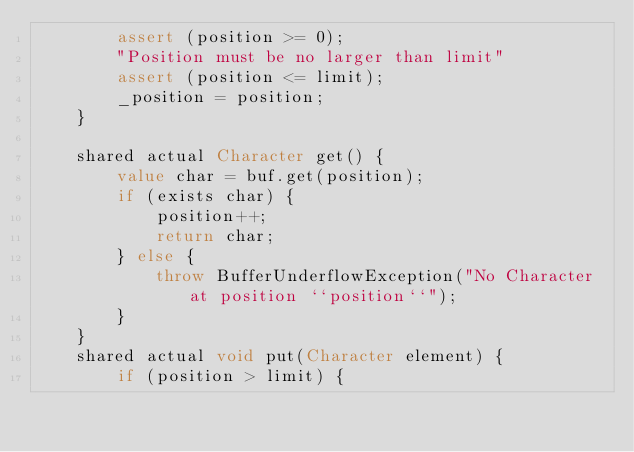Convert code to text. <code><loc_0><loc_0><loc_500><loc_500><_Ceylon_>        assert (position >= 0);
        "Position must be no larger than limit"
        assert (position <= limit);
        _position = position;
    }
    
    shared actual Character get() {
        value char = buf.get(position);
        if (exists char) {
            position++;
            return char;
        } else {
            throw BufferUnderflowException("No Character at position ``position``");
        }
    }
    shared actual void put(Character element) {
        if (position > limit) {</code> 